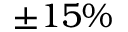<formula> <loc_0><loc_0><loc_500><loc_500>\pm 1 5 \%</formula> 